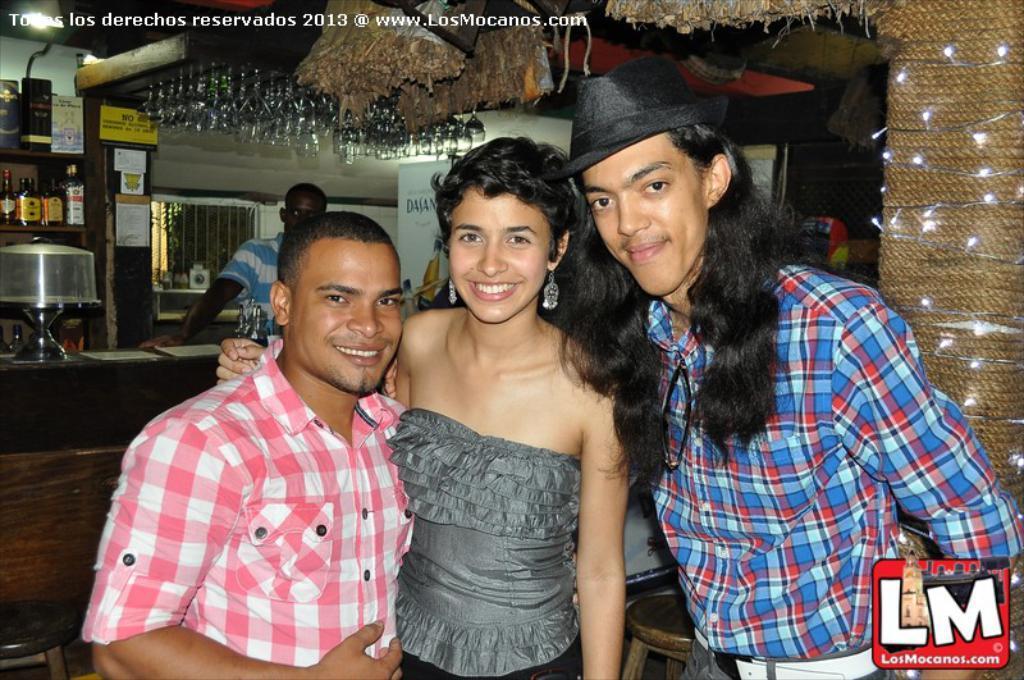How would you summarize this image in a sentence or two? In the center of the image we can see persons standing on the floor. In the background we can see person, counter top, beverage bottle, shelves, window, glass tumblers, refrigerator and wall. 